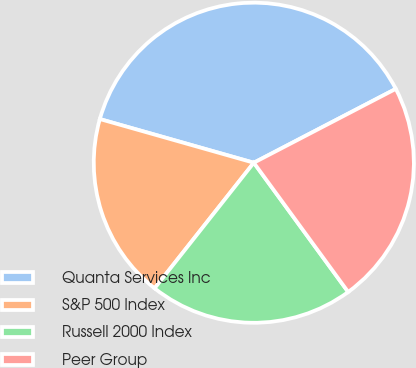Convert chart to OTSL. <chart><loc_0><loc_0><loc_500><loc_500><pie_chart><fcel>Quanta Services Inc<fcel>S&P 500 Index<fcel>Russell 2000 Index<fcel>Peer Group<nl><fcel>37.97%<fcel>18.76%<fcel>20.68%<fcel>22.6%<nl></chart> 